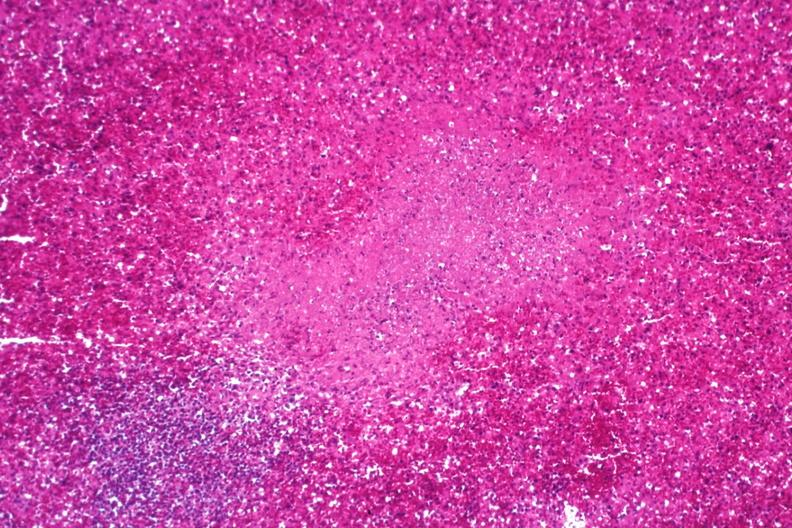does this image show necrotizing granuloma?
Answer the question using a single word or phrase. Yes 